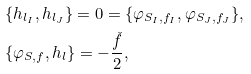<formula> <loc_0><loc_0><loc_500><loc_500>& \{ h _ { l _ { I } } , h _ { l _ { J } } \} = 0 = \{ \varphi _ { S _ { I } , f _ { I } } , \varphi _ { S _ { J } , f _ { J } } \} , \\ & \{ \varphi _ { S , f } , h _ { l } \} = - \frac { \check { f } } { 2 } ,</formula> 